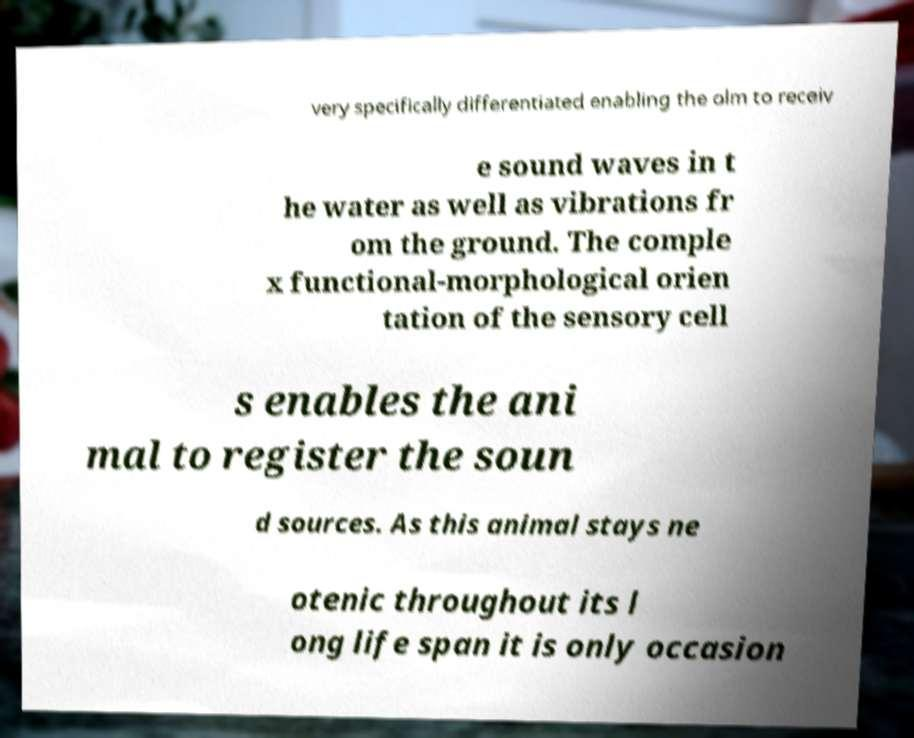Please read and relay the text visible in this image. What does it say? very specifically differentiated enabling the olm to receiv e sound waves in t he water as well as vibrations fr om the ground. The comple x functional-morphological orien tation of the sensory cell s enables the ani mal to register the soun d sources. As this animal stays ne otenic throughout its l ong life span it is only occasion 